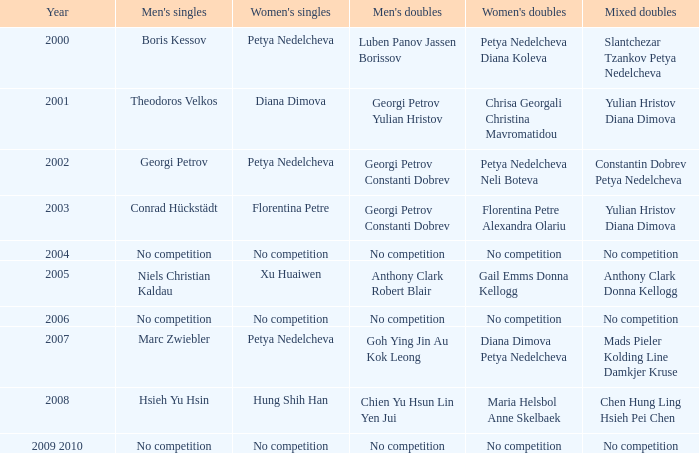Who triumphed in the men's double the same year florentina petre claimed victory in the women's singles? Georgi Petrov Constanti Dobrev. 